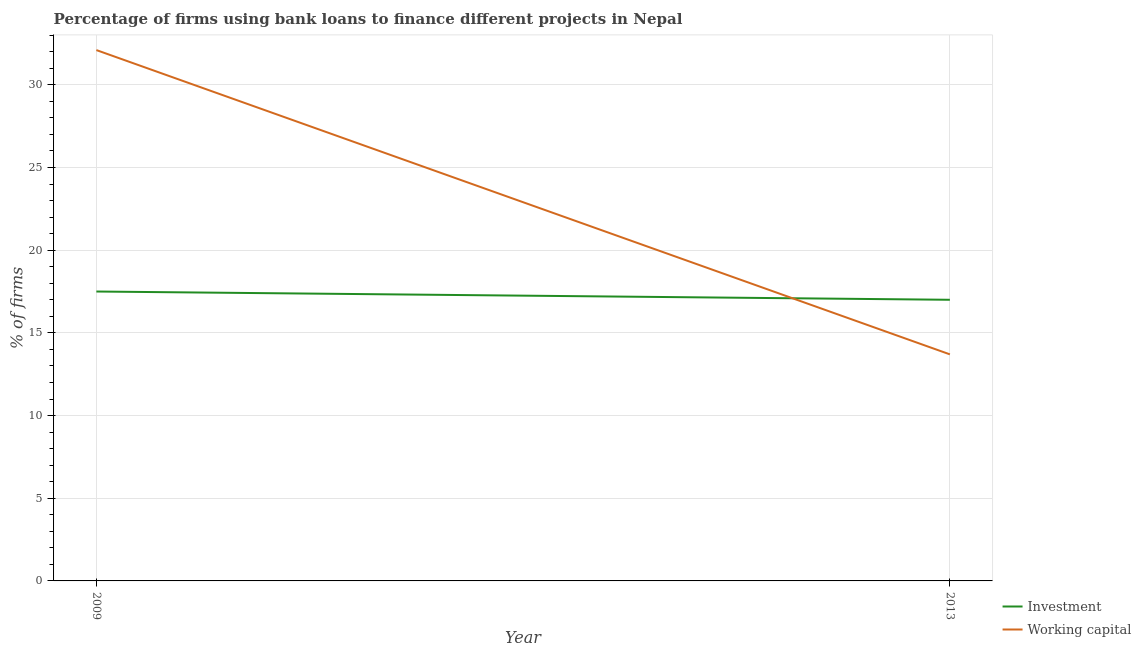How many different coloured lines are there?
Your answer should be compact. 2. Is the number of lines equal to the number of legend labels?
Keep it short and to the point. Yes. What is the percentage of firms using banks to finance working capital in 2009?
Provide a succinct answer. 32.1. Across all years, what is the maximum percentage of firms using banks to finance investment?
Make the answer very short. 17.5. In which year was the percentage of firms using banks to finance working capital maximum?
Your answer should be very brief. 2009. In which year was the percentage of firms using banks to finance investment minimum?
Offer a very short reply. 2013. What is the total percentage of firms using banks to finance investment in the graph?
Provide a succinct answer. 34.5. What is the difference between the percentage of firms using banks to finance investment in 2009 and that in 2013?
Keep it short and to the point. 0.5. What is the difference between the percentage of firms using banks to finance investment in 2009 and the percentage of firms using banks to finance working capital in 2013?
Your answer should be compact. 3.8. What is the average percentage of firms using banks to finance investment per year?
Provide a succinct answer. 17.25. In the year 2013, what is the difference between the percentage of firms using banks to finance investment and percentage of firms using banks to finance working capital?
Keep it short and to the point. 3.3. In how many years, is the percentage of firms using banks to finance investment greater than 2 %?
Your answer should be very brief. 2. What is the ratio of the percentage of firms using banks to finance working capital in 2009 to that in 2013?
Provide a short and direct response. 2.34. Is the percentage of firms using banks to finance investment in 2009 less than that in 2013?
Make the answer very short. No. In how many years, is the percentage of firms using banks to finance investment greater than the average percentage of firms using banks to finance investment taken over all years?
Your answer should be compact. 1. Is the percentage of firms using banks to finance working capital strictly less than the percentage of firms using banks to finance investment over the years?
Offer a very short reply. No. Are the values on the major ticks of Y-axis written in scientific E-notation?
Keep it short and to the point. No. How many legend labels are there?
Offer a terse response. 2. What is the title of the graph?
Keep it short and to the point. Percentage of firms using bank loans to finance different projects in Nepal. Does "Private credit bureau" appear as one of the legend labels in the graph?
Provide a succinct answer. No. What is the label or title of the Y-axis?
Offer a very short reply. % of firms. What is the % of firms of Working capital in 2009?
Offer a terse response. 32.1. Across all years, what is the maximum % of firms in Investment?
Your answer should be very brief. 17.5. Across all years, what is the maximum % of firms in Working capital?
Offer a very short reply. 32.1. Across all years, what is the minimum % of firms in Investment?
Provide a succinct answer. 17. Across all years, what is the minimum % of firms of Working capital?
Provide a succinct answer. 13.7. What is the total % of firms in Investment in the graph?
Keep it short and to the point. 34.5. What is the total % of firms in Working capital in the graph?
Your answer should be compact. 45.8. What is the difference between the % of firms in Investment in 2009 and the % of firms in Working capital in 2013?
Offer a terse response. 3.8. What is the average % of firms of Investment per year?
Ensure brevity in your answer.  17.25. What is the average % of firms of Working capital per year?
Your answer should be compact. 22.9. In the year 2009, what is the difference between the % of firms of Investment and % of firms of Working capital?
Make the answer very short. -14.6. What is the ratio of the % of firms in Investment in 2009 to that in 2013?
Ensure brevity in your answer.  1.03. What is the ratio of the % of firms in Working capital in 2009 to that in 2013?
Your answer should be compact. 2.34. What is the difference between the highest and the second highest % of firms of Investment?
Your response must be concise. 0.5. 